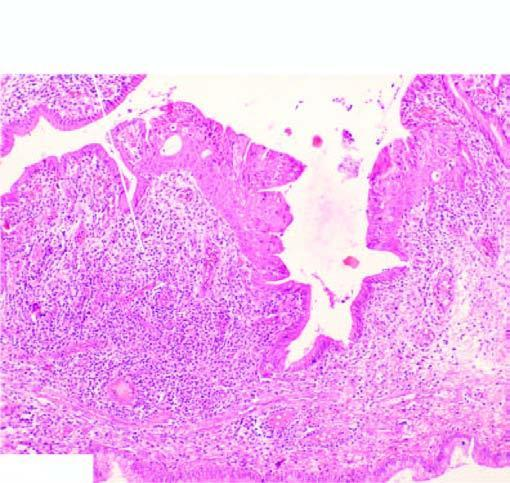re the nucleus lined by normal columnar epithelium while foci of metaplastic squamous epithelium are seen at other places?
Answer the question using a single word or phrase. No 